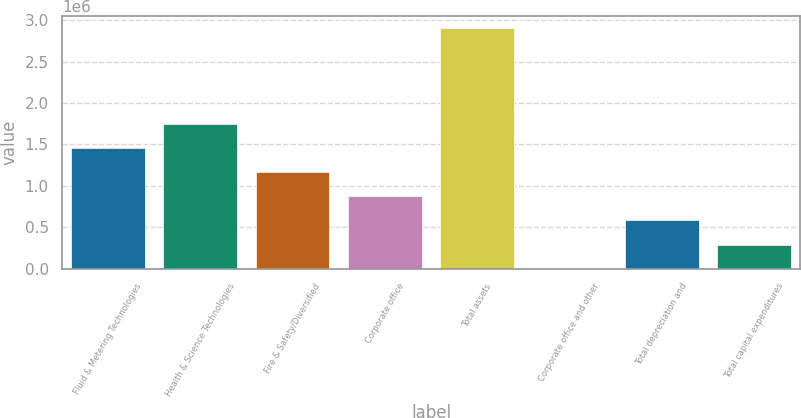Convert chart. <chart><loc_0><loc_0><loc_500><loc_500><bar_chart><fcel>Fluid & Metering Technologies<fcel>Health & Science Technologies<fcel>Fire & Safety/Diversified<fcel>Corporate office<fcel>Total assets<fcel>Corporate office and other<fcel>Total depreciation and<fcel>Total capital expenditures<nl><fcel>1.45473e+06<fcel>1.7454e+06<fcel>1.16406e+06<fcel>873396<fcel>2.90807e+06<fcel>1393<fcel>582728<fcel>292061<nl></chart> 